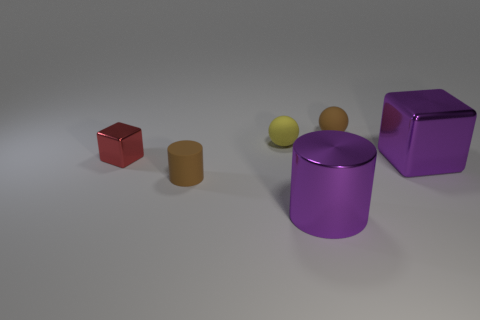Is there anything else that has the same color as the small metallic block?
Your response must be concise. No. What is the material of the large purple thing that is the same shape as the small red shiny thing?
Make the answer very short. Metal. What number of other objects are the same size as the red cube?
Ensure brevity in your answer.  3. The rubber sphere that is the same color as the small matte cylinder is what size?
Your answer should be compact. Small. Is the shape of the tiny brown matte thing that is in front of the tiny yellow matte sphere the same as  the small yellow matte object?
Give a very brief answer. No. What number of other things are the same shape as the tiny red object?
Your answer should be compact. 1. There is a large purple shiny thing to the left of the tiny brown matte ball; what is its shape?
Make the answer very short. Cylinder. Is there a small brown thing made of the same material as the tiny brown cylinder?
Offer a very short reply. Yes. There is a block to the right of the red cube; is its color the same as the large cylinder?
Give a very brief answer. Yes. What size is the brown cylinder?
Offer a very short reply. Small. 